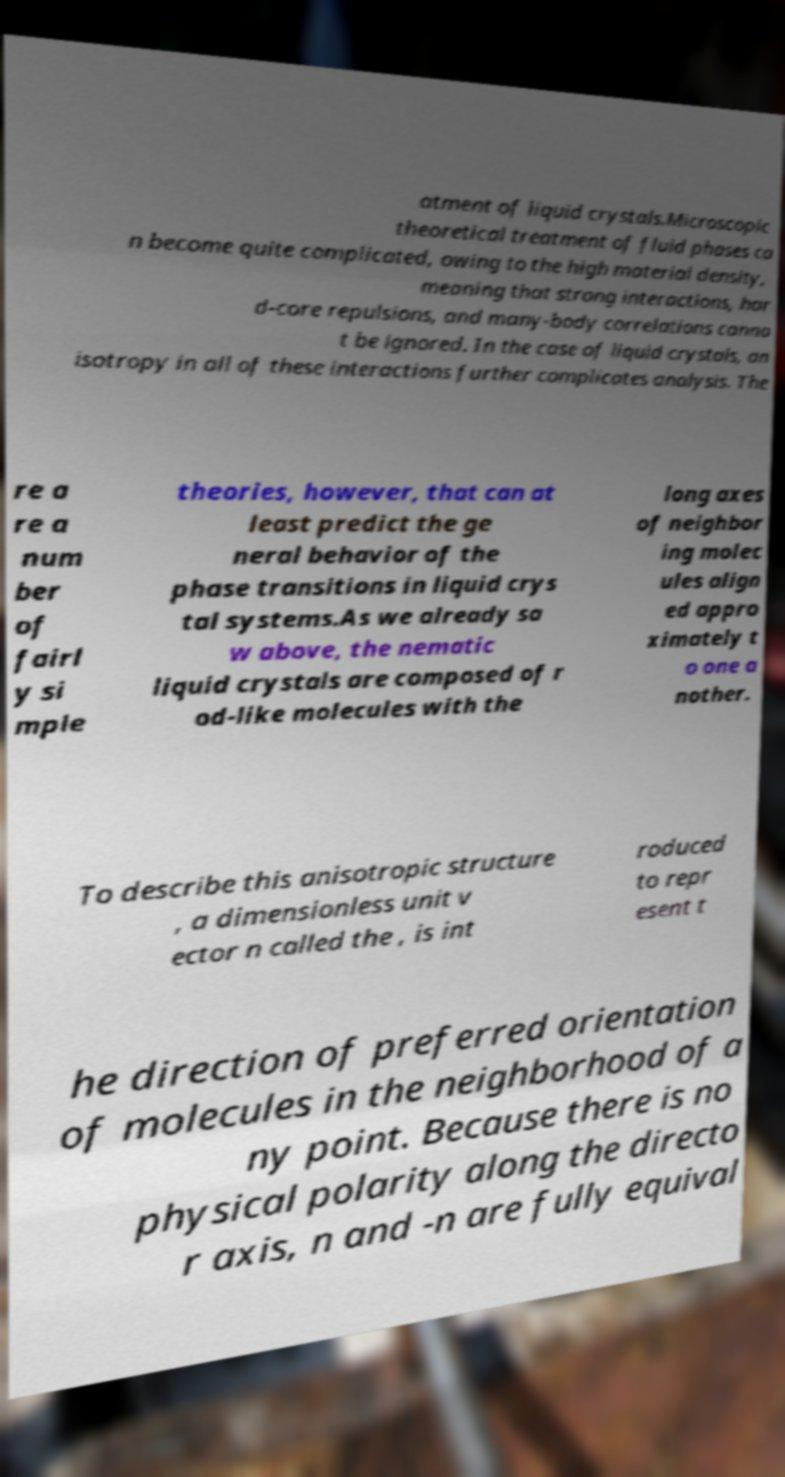Could you extract and type out the text from this image? atment of liquid crystals.Microscopic theoretical treatment of fluid phases ca n become quite complicated, owing to the high material density, meaning that strong interactions, har d-core repulsions, and many-body correlations canno t be ignored. In the case of liquid crystals, an isotropy in all of these interactions further complicates analysis. The re a re a num ber of fairl y si mple theories, however, that can at least predict the ge neral behavior of the phase transitions in liquid crys tal systems.As we already sa w above, the nematic liquid crystals are composed of r od-like molecules with the long axes of neighbor ing molec ules align ed appro ximately t o one a nother. To describe this anisotropic structure , a dimensionless unit v ector n called the , is int roduced to repr esent t he direction of preferred orientation of molecules in the neighborhood of a ny point. Because there is no physical polarity along the directo r axis, n and -n are fully equival 